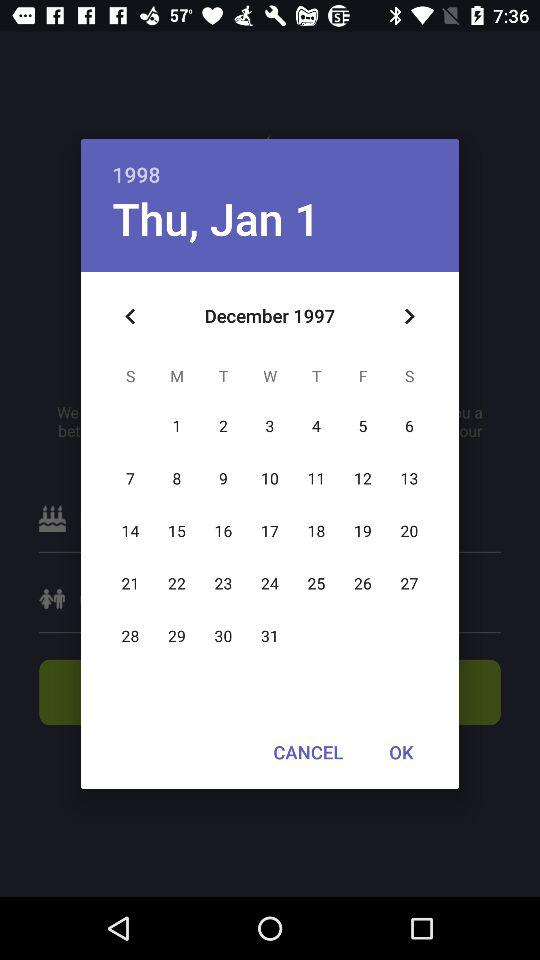How many months are between the two dates shown on the calendar?
Answer the question using a single word or phrase. 1 